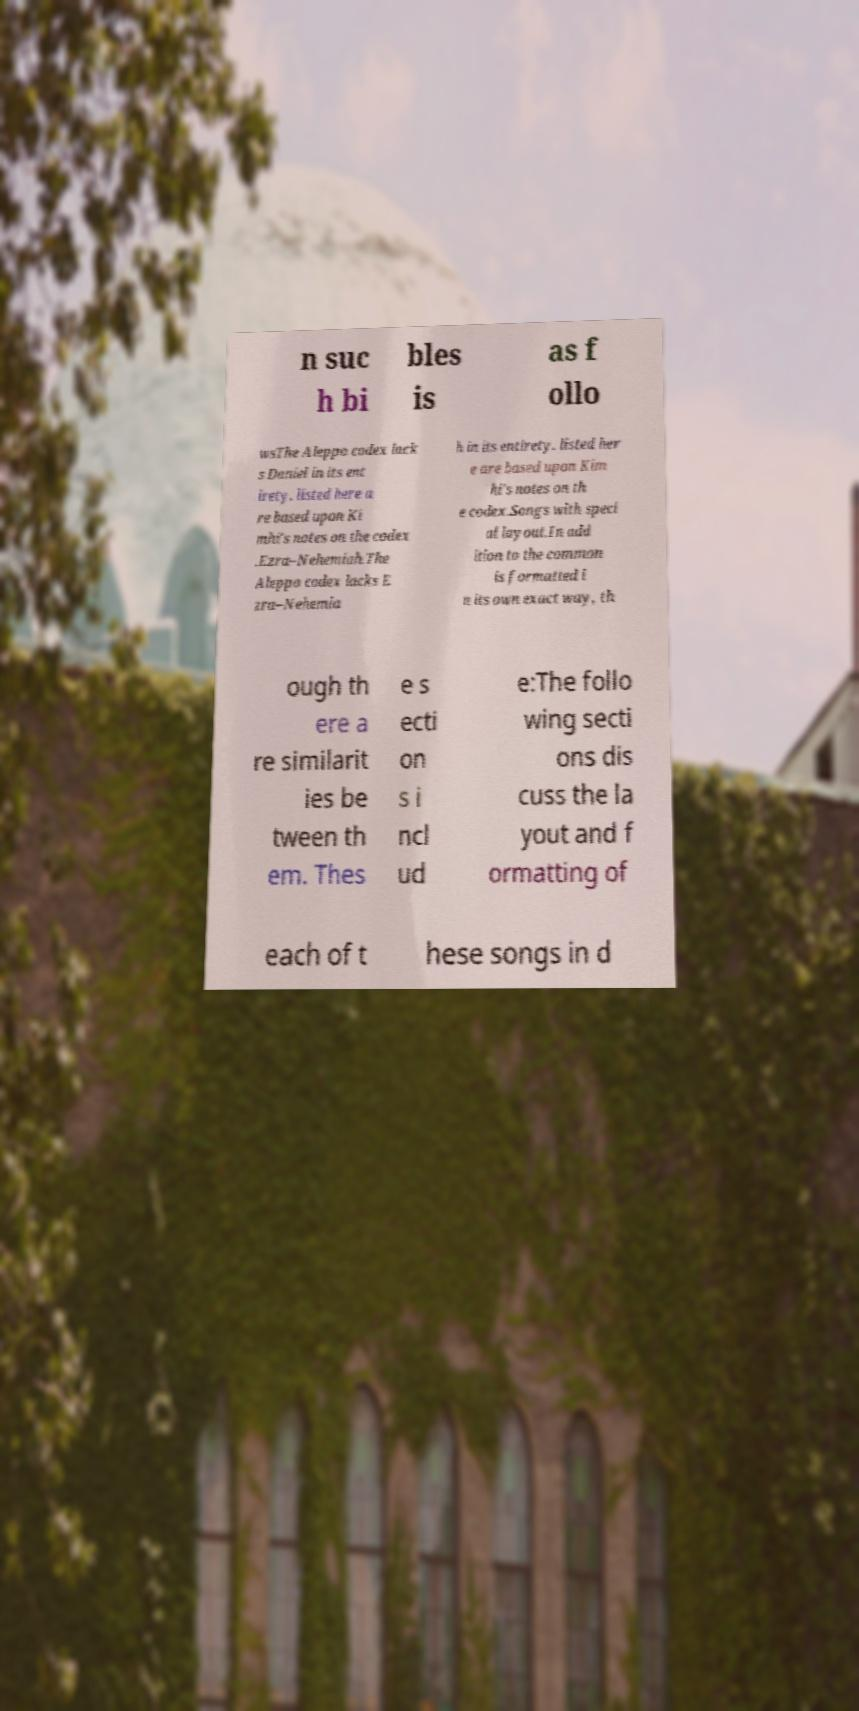For documentation purposes, I need the text within this image transcribed. Could you provide that? n suc h bi bles is as f ollo wsThe Aleppo codex lack s Daniel in its ent irety. listed here a re based upon Ki mhi's notes on the codex .Ezra–Nehemiah.The Aleppo codex lacks E zra–Nehemia h in its entirety. listed her e are based upon Kim hi's notes on th e codex.Songs with speci al layout.In add ition to the common is formatted i n its own exact way, th ough th ere a re similarit ies be tween th em. Thes e s ecti on s i ncl ud e:The follo wing secti ons dis cuss the la yout and f ormatting of each of t hese songs in d 